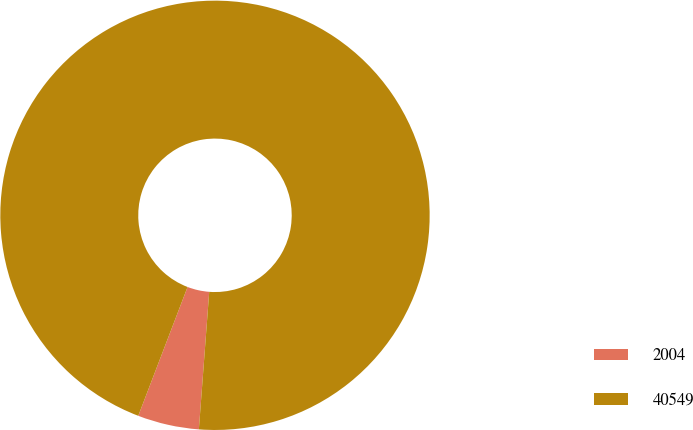Convert chart. <chart><loc_0><loc_0><loc_500><loc_500><pie_chart><fcel>2004<fcel>40549<nl><fcel>4.62%<fcel>95.38%<nl></chart> 